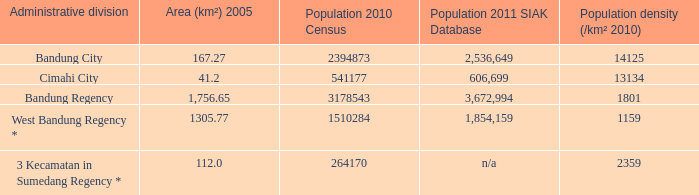What is the size of cimahi city? 41.2. 